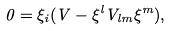Convert formula to latex. <formula><loc_0><loc_0><loc_500><loc_500>0 = \xi _ { i } ( V - \xi ^ { l } V _ { l m } \xi ^ { m } ) ,</formula> 